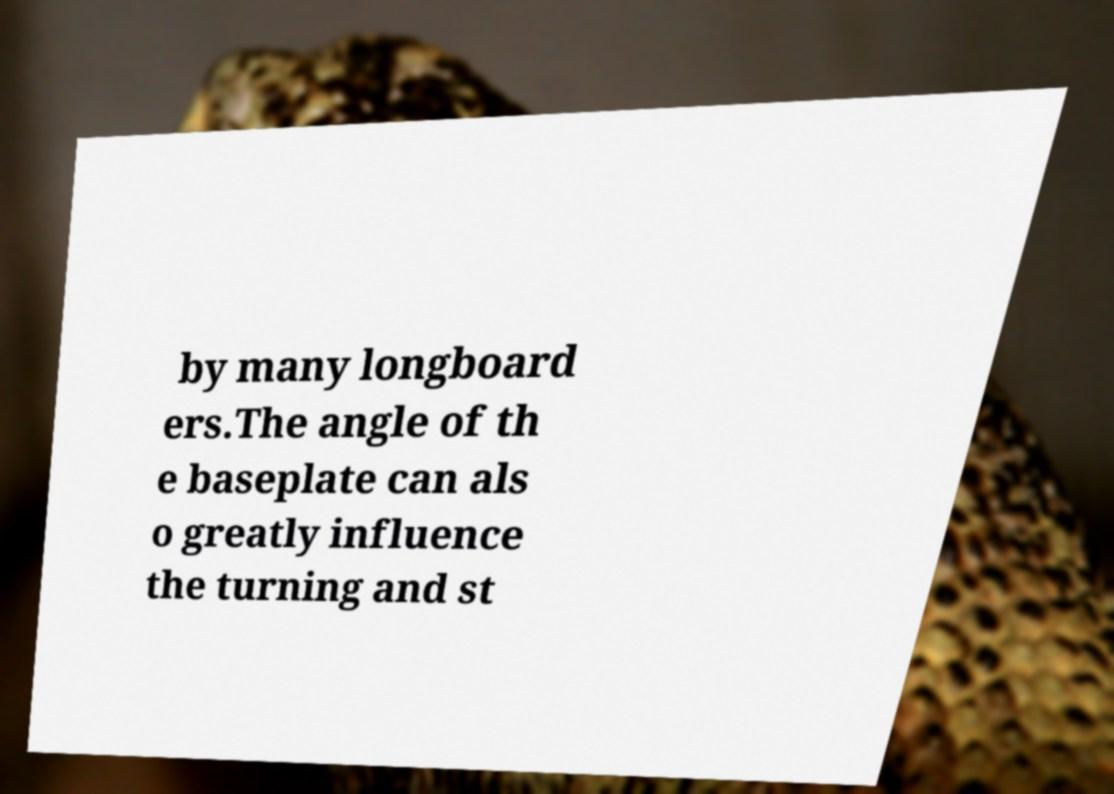There's text embedded in this image that I need extracted. Can you transcribe it verbatim? by many longboard ers.The angle of th e baseplate can als o greatly influence the turning and st 